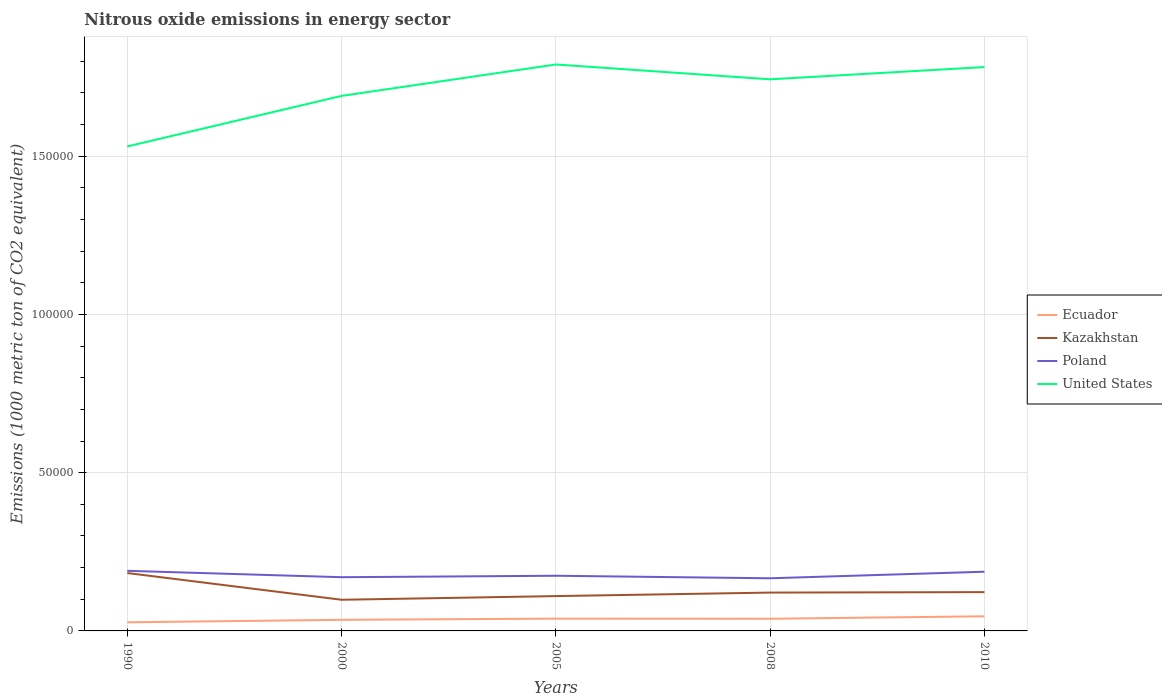Does the line corresponding to Kazakhstan intersect with the line corresponding to Ecuador?
Ensure brevity in your answer.  No. Is the number of lines equal to the number of legend labels?
Provide a succinct answer. Yes. Across all years, what is the maximum amount of nitrous oxide emitted in Kazakhstan?
Ensure brevity in your answer.  9844.3. In which year was the amount of nitrous oxide emitted in Poland maximum?
Your answer should be very brief. 2008. What is the total amount of nitrous oxide emitted in Kazakhstan in the graph?
Your answer should be compact. 7287.5. What is the difference between the highest and the second highest amount of nitrous oxide emitted in Kazakhstan?
Your answer should be compact. 8448.2. Is the amount of nitrous oxide emitted in Kazakhstan strictly greater than the amount of nitrous oxide emitted in United States over the years?
Provide a short and direct response. Yes. How many lines are there?
Offer a very short reply. 4. Are the values on the major ticks of Y-axis written in scientific E-notation?
Make the answer very short. No. Where does the legend appear in the graph?
Provide a short and direct response. Center right. How are the legend labels stacked?
Provide a succinct answer. Vertical. What is the title of the graph?
Make the answer very short. Nitrous oxide emissions in energy sector. What is the label or title of the X-axis?
Give a very brief answer. Years. What is the label or title of the Y-axis?
Make the answer very short. Emissions (1000 metric ton of CO2 equivalent). What is the Emissions (1000 metric ton of CO2 equivalent) in Ecuador in 1990?
Provide a short and direct response. 2718.5. What is the Emissions (1000 metric ton of CO2 equivalent) in Kazakhstan in 1990?
Give a very brief answer. 1.83e+04. What is the Emissions (1000 metric ton of CO2 equivalent) of Poland in 1990?
Your answer should be very brief. 1.90e+04. What is the Emissions (1000 metric ton of CO2 equivalent) in United States in 1990?
Your response must be concise. 1.53e+05. What is the Emissions (1000 metric ton of CO2 equivalent) of Ecuador in 2000?
Make the answer very short. 3508.3. What is the Emissions (1000 metric ton of CO2 equivalent) in Kazakhstan in 2000?
Your answer should be compact. 9844.3. What is the Emissions (1000 metric ton of CO2 equivalent) of Poland in 2000?
Make the answer very short. 1.70e+04. What is the Emissions (1000 metric ton of CO2 equivalent) of United States in 2000?
Your answer should be very brief. 1.69e+05. What is the Emissions (1000 metric ton of CO2 equivalent) in Ecuador in 2005?
Offer a terse response. 3878.5. What is the Emissions (1000 metric ton of CO2 equivalent) of Kazakhstan in 2005?
Your answer should be compact. 1.10e+04. What is the Emissions (1000 metric ton of CO2 equivalent) in Poland in 2005?
Your response must be concise. 1.74e+04. What is the Emissions (1000 metric ton of CO2 equivalent) of United States in 2005?
Your answer should be very brief. 1.79e+05. What is the Emissions (1000 metric ton of CO2 equivalent) of Ecuador in 2008?
Provide a succinct answer. 3846. What is the Emissions (1000 metric ton of CO2 equivalent) of Kazakhstan in 2008?
Your answer should be compact. 1.21e+04. What is the Emissions (1000 metric ton of CO2 equivalent) of Poland in 2008?
Provide a short and direct response. 1.66e+04. What is the Emissions (1000 metric ton of CO2 equivalent) of United States in 2008?
Provide a short and direct response. 1.74e+05. What is the Emissions (1000 metric ton of CO2 equivalent) of Ecuador in 2010?
Your answer should be very brief. 4620.6. What is the Emissions (1000 metric ton of CO2 equivalent) of Kazakhstan in 2010?
Provide a short and direct response. 1.23e+04. What is the Emissions (1000 metric ton of CO2 equivalent) in Poland in 2010?
Offer a terse response. 1.87e+04. What is the Emissions (1000 metric ton of CO2 equivalent) of United States in 2010?
Your answer should be very brief. 1.78e+05. Across all years, what is the maximum Emissions (1000 metric ton of CO2 equivalent) in Ecuador?
Give a very brief answer. 4620.6. Across all years, what is the maximum Emissions (1000 metric ton of CO2 equivalent) in Kazakhstan?
Your response must be concise. 1.83e+04. Across all years, what is the maximum Emissions (1000 metric ton of CO2 equivalent) in Poland?
Ensure brevity in your answer.  1.90e+04. Across all years, what is the maximum Emissions (1000 metric ton of CO2 equivalent) in United States?
Your answer should be compact. 1.79e+05. Across all years, what is the minimum Emissions (1000 metric ton of CO2 equivalent) in Ecuador?
Offer a terse response. 2718.5. Across all years, what is the minimum Emissions (1000 metric ton of CO2 equivalent) in Kazakhstan?
Keep it short and to the point. 9844.3. Across all years, what is the minimum Emissions (1000 metric ton of CO2 equivalent) of Poland?
Your answer should be compact. 1.66e+04. Across all years, what is the minimum Emissions (1000 metric ton of CO2 equivalent) of United States?
Your answer should be compact. 1.53e+05. What is the total Emissions (1000 metric ton of CO2 equivalent) in Ecuador in the graph?
Provide a succinct answer. 1.86e+04. What is the total Emissions (1000 metric ton of CO2 equivalent) in Kazakhstan in the graph?
Make the answer very short. 6.35e+04. What is the total Emissions (1000 metric ton of CO2 equivalent) of Poland in the graph?
Your answer should be compact. 8.87e+04. What is the total Emissions (1000 metric ton of CO2 equivalent) in United States in the graph?
Keep it short and to the point. 8.54e+05. What is the difference between the Emissions (1000 metric ton of CO2 equivalent) in Ecuador in 1990 and that in 2000?
Give a very brief answer. -789.8. What is the difference between the Emissions (1000 metric ton of CO2 equivalent) of Kazakhstan in 1990 and that in 2000?
Provide a short and direct response. 8448.2. What is the difference between the Emissions (1000 metric ton of CO2 equivalent) of Poland in 1990 and that in 2000?
Offer a very short reply. 2018.2. What is the difference between the Emissions (1000 metric ton of CO2 equivalent) in United States in 1990 and that in 2000?
Offer a very short reply. -1.60e+04. What is the difference between the Emissions (1000 metric ton of CO2 equivalent) in Ecuador in 1990 and that in 2005?
Provide a succinct answer. -1160. What is the difference between the Emissions (1000 metric ton of CO2 equivalent) in Kazakhstan in 1990 and that in 2005?
Your answer should be compact. 7287.5. What is the difference between the Emissions (1000 metric ton of CO2 equivalent) of Poland in 1990 and that in 2005?
Provide a succinct answer. 1561.1. What is the difference between the Emissions (1000 metric ton of CO2 equivalent) of United States in 1990 and that in 2005?
Give a very brief answer. -2.59e+04. What is the difference between the Emissions (1000 metric ton of CO2 equivalent) of Ecuador in 1990 and that in 2008?
Offer a terse response. -1127.5. What is the difference between the Emissions (1000 metric ton of CO2 equivalent) in Kazakhstan in 1990 and that in 2008?
Your answer should be compact. 6177.4. What is the difference between the Emissions (1000 metric ton of CO2 equivalent) in Poland in 1990 and that in 2008?
Ensure brevity in your answer.  2360.6. What is the difference between the Emissions (1000 metric ton of CO2 equivalent) of United States in 1990 and that in 2008?
Offer a very short reply. -2.12e+04. What is the difference between the Emissions (1000 metric ton of CO2 equivalent) in Ecuador in 1990 and that in 2010?
Make the answer very short. -1902.1. What is the difference between the Emissions (1000 metric ton of CO2 equivalent) in Kazakhstan in 1990 and that in 2010?
Your answer should be very brief. 6035.5. What is the difference between the Emissions (1000 metric ton of CO2 equivalent) in Poland in 1990 and that in 2010?
Offer a very short reply. 287.1. What is the difference between the Emissions (1000 metric ton of CO2 equivalent) of United States in 1990 and that in 2010?
Make the answer very short. -2.51e+04. What is the difference between the Emissions (1000 metric ton of CO2 equivalent) in Ecuador in 2000 and that in 2005?
Provide a short and direct response. -370.2. What is the difference between the Emissions (1000 metric ton of CO2 equivalent) in Kazakhstan in 2000 and that in 2005?
Keep it short and to the point. -1160.7. What is the difference between the Emissions (1000 metric ton of CO2 equivalent) of Poland in 2000 and that in 2005?
Your answer should be very brief. -457.1. What is the difference between the Emissions (1000 metric ton of CO2 equivalent) in United States in 2000 and that in 2005?
Make the answer very short. -9931.2. What is the difference between the Emissions (1000 metric ton of CO2 equivalent) of Ecuador in 2000 and that in 2008?
Keep it short and to the point. -337.7. What is the difference between the Emissions (1000 metric ton of CO2 equivalent) of Kazakhstan in 2000 and that in 2008?
Keep it short and to the point. -2270.8. What is the difference between the Emissions (1000 metric ton of CO2 equivalent) in Poland in 2000 and that in 2008?
Your answer should be compact. 342.4. What is the difference between the Emissions (1000 metric ton of CO2 equivalent) in United States in 2000 and that in 2008?
Your response must be concise. -5242.4. What is the difference between the Emissions (1000 metric ton of CO2 equivalent) of Ecuador in 2000 and that in 2010?
Offer a terse response. -1112.3. What is the difference between the Emissions (1000 metric ton of CO2 equivalent) in Kazakhstan in 2000 and that in 2010?
Offer a terse response. -2412.7. What is the difference between the Emissions (1000 metric ton of CO2 equivalent) in Poland in 2000 and that in 2010?
Give a very brief answer. -1731.1. What is the difference between the Emissions (1000 metric ton of CO2 equivalent) in United States in 2000 and that in 2010?
Provide a succinct answer. -9113.5. What is the difference between the Emissions (1000 metric ton of CO2 equivalent) in Ecuador in 2005 and that in 2008?
Provide a succinct answer. 32.5. What is the difference between the Emissions (1000 metric ton of CO2 equivalent) in Kazakhstan in 2005 and that in 2008?
Give a very brief answer. -1110.1. What is the difference between the Emissions (1000 metric ton of CO2 equivalent) of Poland in 2005 and that in 2008?
Your answer should be very brief. 799.5. What is the difference between the Emissions (1000 metric ton of CO2 equivalent) of United States in 2005 and that in 2008?
Give a very brief answer. 4688.8. What is the difference between the Emissions (1000 metric ton of CO2 equivalent) of Ecuador in 2005 and that in 2010?
Your answer should be very brief. -742.1. What is the difference between the Emissions (1000 metric ton of CO2 equivalent) of Kazakhstan in 2005 and that in 2010?
Your answer should be compact. -1252. What is the difference between the Emissions (1000 metric ton of CO2 equivalent) in Poland in 2005 and that in 2010?
Keep it short and to the point. -1274. What is the difference between the Emissions (1000 metric ton of CO2 equivalent) of United States in 2005 and that in 2010?
Your answer should be very brief. 817.7. What is the difference between the Emissions (1000 metric ton of CO2 equivalent) of Ecuador in 2008 and that in 2010?
Offer a terse response. -774.6. What is the difference between the Emissions (1000 metric ton of CO2 equivalent) of Kazakhstan in 2008 and that in 2010?
Offer a very short reply. -141.9. What is the difference between the Emissions (1000 metric ton of CO2 equivalent) of Poland in 2008 and that in 2010?
Your response must be concise. -2073.5. What is the difference between the Emissions (1000 metric ton of CO2 equivalent) of United States in 2008 and that in 2010?
Your answer should be compact. -3871.1. What is the difference between the Emissions (1000 metric ton of CO2 equivalent) of Ecuador in 1990 and the Emissions (1000 metric ton of CO2 equivalent) of Kazakhstan in 2000?
Provide a succinct answer. -7125.8. What is the difference between the Emissions (1000 metric ton of CO2 equivalent) in Ecuador in 1990 and the Emissions (1000 metric ton of CO2 equivalent) in Poland in 2000?
Your answer should be very brief. -1.43e+04. What is the difference between the Emissions (1000 metric ton of CO2 equivalent) of Ecuador in 1990 and the Emissions (1000 metric ton of CO2 equivalent) of United States in 2000?
Ensure brevity in your answer.  -1.66e+05. What is the difference between the Emissions (1000 metric ton of CO2 equivalent) of Kazakhstan in 1990 and the Emissions (1000 metric ton of CO2 equivalent) of Poland in 2000?
Your answer should be compact. 1320. What is the difference between the Emissions (1000 metric ton of CO2 equivalent) in Kazakhstan in 1990 and the Emissions (1000 metric ton of CO2 equivalent) in United States in 2000?
Provide a short and direct response. -1.51e+05. What is the difference between the Emissions (1000 metric ton of CO2 equivalent) of Poland in 1990 and the Emissions (1000 metric ton of CO2 equivalent) of United States in 2000?
Offer a very short reply. -1.50e+05. What is the difference between the Emissions (1000 metric ton of CO2 equivalent) of Ecuador in 1990 and the Emissions (1000 metric ton of CO2 equivalent) of Kazakhstan in 2005?
Keep it short and to the point. -8286.5. What is the difference between the Emissions (1000 metric ton of CO2 equivalent) in Ecuador in 1990 and the Emissions (1000 metric ton of CO2 equivalent) in Poland in 2005?
Your answer should be very brief. -1.47e+04. What is the difference between the Emissions (1000 metric ton of CO2 equivalent) in Ecuador in 1990 and the Emissions (1000 metric ton of CO2 equivalent) in United States in 2005?
Offer a terse response. -1.76e+05. What is the difference between the Emissions (1000 metric ton of CO2 equivalent) in Kazakhstan in 1990 and the Emissions (1000 metric ton of CO2 equivalent) in Poland in 2005?
Keep it short and to the point. 862.9. What is the difference between the Emissions (1000 metric ton of CO2 equivalent) in Kazakhstan in 1990 and the Emissions (1000 metric ton of CO2 equivalent) in United States in 2005?
Offer a terse response. -1.61e+05. What is the difference between the Emissions (1000 metric ton of CO2 equivalent) in Poland in 1990 and the Emissions (1000 metric ton of CO2 equivalent) in United States in 2005?
Your answer should be very brief. -1.60e+05. What is the difference between the Emissions (1000 metric ton of CO2 equivalent) in Ecuador in 1990 and the Emissions (1000 metric ton of CO2 equivalent) in Kazakhstan in 2008?
Your answer should be very brief. -9396.6. What is the difference between the Emissions (1000 metric ton of CO2 equivalent) of Ecuador in 1990 and the Emissions (1000 metric ton of CO2 equivalent) of Poland in 2008?
Give a very brief answer. -1.39e+04. What is the difference between the Emissions (1000 metric ton of CO2 equivalent) of Ecuador in 1990 and the Emissions (1000 metric ton of CO2 equivalent) of United States in 2008?
Keep it short and to the point. -1.72e+05. What is the difference between the Emissions (1000 metric ton of CO2 equivalent) of Kazakhstan in 1990 and the Emissions (1000 metric ton of CO2 equivalent) of Poland in 2008?
Make the answer very short. 1662.4. What is the difference between the Emissions (1000 metric ton of CO2 equivalent) of Kazakhstan in 1990 and the Emissions (1000 metric ton of CO2 equivalent) of United States in 2008?
Make the answer very short. -1.56e+05. What is the difference between the Emissions (1000 metric ton of CO2 equivalent) of Poland in 1990 and the Emissions (1000 metric ton of CO2 equivalent) of United States in 2008?
Your answer should be compact. -1.55e+05. What is the difference between the Emissions (1000 metric ton of CO2 equivalent) of Ecuador in 1990 and the Emissions (1000 metric ton of CO2 equivalent) of Kazakhstan in 2010?
Provide a succinct answer. -9538.5. What is the difference between the Emissions (1000 metric ton of CO2 equivalent) in Ecuador in 1990 and the Emissions (1000 metric ton of CO2 equivalent) in Poland in 2010?
Ensure brevity in your answer.  -1.60e+04. What is the difference between the Emissions (1000 metric ton of CO2 equivalent) in Ecuador in 1990 and the Emissions (1000 metric ton of CO2 equivalent) in United States in 2010?
Provide a succinct answer. -1.75e+05. What is the difference between the Emissions (1000 metric ton of CO2 equivalent) in Kazakhstan in 1990 and the Emissions (1000 metric ton of CO2 equivalent) in Poland in 2010?
Your answer should be very brief. -411.1. What is the difference between the Emissions (1000 metric ton of CO2 equivalent) in Kazakhstan in 1990 and the Emissions (1000 metric ton of CO2 equivalent) in United States in 2010?
Your response must be concise. -1.60e+05. What is the difference between the Emissions (1000 metric ton of CO2 equivalent) of Poland in 1990 and the Emissions (1000 metric ton of CO2 equivalent) of United States in 2010?
Your response must be concise. -1.59e+05. What is the difference between the Emissions (1000 metric ton of CO2 equivalent) of Ecuador in 2000 and the Emissions (1000 metric ton of CO2 equivalent) of Kazakhstan in 2005?
Your response must be concise. -7496.7. What is the difference between the Emissions (1000 metric ton of CO2 equivalent) of Ecuador in 2000 and the Emissions (1000 metric ton of CO2 equivalent) of Poland in 2005?
Give a very brief answer. -1.39e+04. What is the difference between the Emissions (1000 metric ton of CO2 equivalent) in Ecuador in 2000 and the Emissions (1000 metric ton of CO2 equivalent) in United States in 2005?
Offer a terse response. -1.75e+05. What is the difference between the Emissions (1000 metric ton of CO2 equivalent) of Kazakhstan in 2000 and the Emissions (1000 metric ton of CO2 equivalent) of Poland in 2005?
Provide a short and direct response. -7585.3. What is the difference between the Emissions (1000 metric ton of CO2 equivalent) of Kazakhstan in 2000 and the Emissions (1000 metric ton of CO2 equivalent) of United States in 2005?
Ensure brevity in your answer.  -1.69e+05. What is the difference between the Emissions (1000 metric ton of CO2 equivalent) of Poland in 2000 and the Emissions (1000 metric ton of CO2 equivalent) of United States in 2005?
Your response must be concise. -1.62e+05. What is the difference between the Emissions (1000 metric ton of CO2 equivalent) of Ecuador in 2000 and the Emissions (1000 metric ton of CO2 equivalent) of Kazakhstan in 2008?
Keep it short and to the point. -8606.8. What is the difference between the Emissions (1000 metric ton of CO2 equivalent) of Ecuador in 2000 and the Emissions (1000 metric ton of CO2 equivalent) of Poland in 2008?
Make the answer very short. -1.31e+04. What is the difference between the Emissions (1000 metric ton of CO2 equivalent) in Ecuador in 2000 and the Emissions (1000 metric ton of CO2 equivalent) in United States in 2008?
Provide a short and direct response. -1.71e+05. What is the difference between the Emissions (1000 metric ton of CO2 equivalent) of Kazakhstan in 2000 and the Emissions (1000 metric ton of CO2 equivalent) of Poland in 2008?
Offer a terse response. -6785.8. What is the difference between the Emissions (1000 metric ton of CO2 equivalent) of Kazakhstan in 2000 and the Emissions (1000 metric ton of CO2 equivalent) of United States in 2008?
Ensure brevity in your answer.  -1.64e+05. What is the difference between the Emissions (1000 metric ton of CO2 equivalent) in Poland in 2000 and the Emissions (1000 metric ton of CO2 equivalent) in United States in 2008?
Keep it short and to the point. -1.57e+05. What is the difference between the Emissions (1000 metric ton of CO2 equivalent) in Ecuador in 2000 and the Emissions (1000 metric ton of CO2 equivalent) in Kazakhstan in 2010?
Your answer should be compact. -8748.7. What is the difference between the Emissions (1000 metric ton of CO2 equivalent) in Ecuador in 2000 and the Emissions (1000 metric ton of CO2 equivalent) in Poland in 2010?
Give a very brief answer. -1.52e+04. What is the difference between the Emissions (1000 metric ton of CO2 equivalent) of Ecuador in 2000 and the Emissions (1000 metric ton of CO2 equivalent) of United States in 2010?
Give a very brief answer. -1.75e+05. What is the difference between the Emissions (1000 metric ton of CO2 equivalent) of Kazakhstan in 2000 and the Emissions (1000 metric ton of CO2 equivalent) of Poland in 2010?
Ensure brevity in your answer.  -8859.3. What is the difference between the Emissions (1000 metric ton of CO2 equivalent) in Kazakhstan in 2000 and the Emissions (1000 metric ton of CO2 equivalent) in United States in 2010?
Provide a short and direct response. -1.68e+05. What is the difference between the Emissions (1000 metric ton of CO2 equivalent) of Poland in 2000 and the Emissions (1000 metric ton of CO2 equivalent) of United States in 2010?
Offer a very short reply. -1.61e+05. What is the difference between the Emissions (1000 metric ton of CO2 equivalent) of Ecuador in 2005 and the Emissions (1000 metric ton of CO2 equivalent) of Kazakhstan in 2008?
Your answer should be very brief. -8236.6. What is the difference between the Emissions (1000 metric ton of CO2 equivalent) in Ecuador in 2005 and the Emissions (1000 metric ton of CO2 equivalent) in Poland in 2008?
Offer a very short reply. -1.28e+04. What is the difference between the Emissions (1000 metric ton of CO2 equivalent) of Ecuador in 2005 and the Emissions (1000 metric ton of CO2 equivalent) of United States in 2008?
Your response must be concise. -1.70e+05. What is the difference between the Emissions (1000 metric ton of CO2 equivalent) of Kazakhstan in 2005 and the Emissions (1000 metric ton of CO2 equivalent) of Poland in 2008?
Provide a short and direct response. -5625.1. What is the difference between the Emissions (1000 metric ton of CO2 equivalent) of Kazakhstan in 2005 and the Emissions (1000 metric ton of CO2 equivalent) of United States in 2008?
Give a very brief answer. -1.63e+05. What is the difference between the Emissions (1000 metric ton of CO2 equivalent) in Poland in 2005 and the Emissions (1000 metric ton of CO2 equivalent) in United States in 2008?
Give a very brief answer. -1.57e+05. What is the difference between the Emissions (1000 metric ton of CO2 equivalent) in Ecuador in 2005 and the Emissions (1000 metric ton of CO2 equivalent) in Kazakhstan in 2010?
Your answer should be very brief. -8378.5. What is the difference between the Emissions (1000 metric ton of CO2 equivalent) in Ecuador in 2005 and the Emissions (1000 metric ton of CO2 equivalent) in Poland in 2010?
Make the answer very short. -1.48e+04. What is the difference between the Emissions (1000 metric ton of CO2 equivalent) in Ecuador in 2005 and the Emissions (1000 metric ton of CO2 equivalent) in United States in 2010?
Offer a very short reply. -1.74e+05. What is the difference between the Emissions (1000 metric ton of CO2 equivalent) of Kazakhstan in 2005 and the Emissions (1000 metric ton of CO2 equivalent) of Poland in 2010?
Provide a succinct answer. -7698.6. What is the difference between the Emissions (1000 metric ton of CO2 equivalent) in Kazakhstan in 2005 and the Emissions (1000 metric ton of CO2 equivalent) in United States in 2010?
Provide a succinct answer. -1.67e+05. What is the difference between the Emissions (1000 metric ton of CO2 equivalent) of Poland in 2005 and the Emissions (1000 metric ton of CO2 equivalent) of United States in 2010?
Your answer should be compact. -1.61e+05. What is the difference between the Emissions (1000 metric ton of CO2 equivalent) of Ecuador in 2008 and the Emissions (1000 metric ton of CO2 equivalent) of Kazakhstan in 2010?
Your answer should be very brief. -8411. What is the difference between the Emissions (1000 metric ton of CO2 equivalent) in Ecuador in 2008 and the Emissions (1000 metric ton of CO2 equivalent) in Poland in 2010?
Ensure brevity in your answer.  -1.49e+04. What is the difference between the Emissions (1000 metric ton of CO2 equivalent) in Ecuador in 2008 and the Emissions (1000 metric ton of CO2 equivalent) in United States in 2010?
Keep it short and to the point. -1.74e+05. What is the difference between the Emissions (1000 metric ton of CO2 equivalent) of Kazakhstan in 2008 and the Emissions (1000 metric ton of CO2 equivalent) of Poland in 2010?
Keep it short and to the point. -6588.5. What is the difference between the Emissions (1000 metric ton of CO2 equivalent) in Kazakhstan in 2008 and the Emissions (1000 metric ton of CO2 equivalent) in United States in 2010?
Ensure brevity in your answer.  -1.66e+05. What is the difference between the Emissions (1000 metric ton of CO2 equivalent) in Poland in 2008 and the Emissions (1000 metric ton of CO2 equivalent) in United States in 2010?
Keep it short and to the point. -1.62e+05. What is the average Emissions (1000 metric ton of CO2 equivalent) of Ecuador per year?
Your answer should be very brief. 3714.38. What is the average Emissions (1000 metric ton of CO2 equivalent) of Kazakhstan per year?
Give a very brief answer. 1.27e+04. What is the average Emissions (1000 metric ton of CO2 equivalent) of Poland per year?
Make the answer very short. 1.77e+04. What is the average Emissions (1000 metric ton of CO2 equivalent) of United States per year?
Your response must be concise. 1.71e+05. In the year 1990, what is the difference between the Emissions (1000 metric ton of CO2 equivalent) of Ecuador and Emissions (1000 metric ton of CO2 equivalent) of Kazakhstan?
Ensure brevity in your answer.  -1.56e+04. In the year 1990, what is the difference between the Emissions (1000 metric ton of CO2 equivalent) in Ecuador and Emissions (1000 metric ton of CO2 equivalent) in Poland?
Your answer should be very brief. -1.63e+04. In the year 1990, what is the difference between the Emissions (1000 metric ton of CO2 equivalent) in Ecuador and Emissions (1000 metric ton of CO2 equivalent) in United States?
Offer a terse response. -1.50e+05. In the year 1990, what is the difference between the Emissions (1000 metric ton of CO2 equivalent) in Kazakhstan and Emissions (1000 metric ton of CO2 equivalent) in Poland?
Give a very brief answer. -698.2. In the year 1990, what is the difference between the Emissions (1000 metric ton of CO2 equivalent) in Kazakhstan and Emissions (1000 metric ton of CO2 equivalent) in United States?
Make the answer very short. -1.35e+05. In the year 1990, what is the difference between the Emissions (1000 metric ton of CO2 equivalent) of Poland and Emissions (1000 metric ton of CO2 equivalent) of United States?
Keep it short and to the point. -1.34e+05. In the year 2000, what is the difference between the Emissions (1000 metric ton of CO2 equivalent) of Ecuador and Emissions (1000 metric ton of CO2 equivalent) of Kazakhstan?
Keep it short and to the point. -6336. In the year 2000, what is the difference between the Emissions (1000 metric ton of CO2 equivalent) in Ecuador and Emissions (1000 metric ton of CO2 equivalent) in Poland?
Give a very brief answer. -1.35e+04. In the year 2000, what is the difference between the Emissions (1000 metric ton of CO2 equivalent) of Ecuador and Emissions (1000 metric ton of CO2 equivalent) of United States?
Keep it short and to the point. -1.66e+05. In the year 2000, what is the difference between the Emissions (1000 metric ton of CO2 equivalent) of Kazakhstan and Emissions (1000 metric ton of CO2 equivalent) of Poland?
Offer a terse response. -7128.2. In the year 2000, what is the difference between the Emissions (1000 metric ton of CO2 equivalent) of Kazakhstan and Emissions (1000 metric ton of CO2 equivalent) of United States?
Ensure brevity in your answer.  -1.59e+05. In the year 2000, what is the difference between the Emissions (1000 metric ton of CO2 equivalent) of Poland and Emissions (1000 metric ton of CO2 equivalent) of United States?
Provide a short and direct response. -1.52e+05. In the year 2005, what is the difference between the Emissions (1000 metric ton of CO2 equivalent) of Ecuador and Emissions (1000 metric ton of CO2 equivalent) of Kazakhstan?
Keep it short and to the point. -7126.5. In the year 2005, what is the difference between the Emissions (1000 metric ton of CO2 equivalent) in Ecuador and Emissions (1000 metric ton of CO2 equivalent) in Poland?
Provide a short and direct response. -1.36e+04. In the year 2005, what is the difference between the Emissions (1000 metric ton of CO2 equivalent) of Ecuador and Emissions (1000 metric ton of CO2 equivalent) of United States?
Your response must be concise. -1.75e+05. In the year 2005, what is the difference between the Emissions (1000 metric ton of CO2 equivalent) of Kazakhstan and Emissions (1000 metric ton of CO2 equivalent) of Poland?
Your response must be concise. -6424.6. In the year 2005, what is the difference between the Emissions (1000 metric ton of CO2 equivalent) of Kazakhstan and Emissions (1000 metric ton of CO2 equivalent) of United States?
Keep it short and to the point. -1.68e+05. In the year 2005, what is the difference between the Emissions (1000 metric ton of CO2 equivalent) of Poland and Emissions (1000 metric ton of CO2 equivalent) of United States?
Provide a succinct answer. -1.62e+05. In the year 2008, what is the difference between the Emissions (1000 metric ton of CO2 equivalent) in Ecuador and Emissions (1000 metric ton of CO2 equivalent) in Kazakhstan?
Provide a short and direct response. -8269.1. In the year 2008, what is the difference between the Emissions (1000 metric ton of CO2 equivalent) of Ecuador and Emissions (1000 metric ton of CO2 equivalent) of Poland?
Provide a succinct answer. -1.28e+04. In the year 2008, what is the difference between the Emissions (1000 metric ton of CO2 equivalent) in Ecuador and Emissions (1000 metric ton of CO2 equivalent) in United States?
Keep it short and to the point. -1.70e+05. In the year 2008, what is the difference between the Emissions (1000 metric ton of CO2 equivalent) of Kazakhstan and Emissions (1000 metric ton of CO2 equivalent) of Poland?
Give a very brief answer. -4515. In the year 2008, what is the difference between the Emissions (1000 metric ton of CO2 equivalent) of Kazakhstan and Emissions (1000 metric ton of CO2 equivalent) of United States?
Ensure brevity in your answer.  -1.62e+05. In the year 2008, what is the difference between the Emissions (1000 metric ton of CO2 equivalent) in Poland and Emissions (1000 metric ton of CO2 equivalent) in United States?
Make the answer very short. -1.58e+05. In the year 2010, what is the difference between the Emissions (1000 metric ton of CO2 equivalent) in Ecuador and Emissions (1000 metric ton of CO2 equivalent) in Kazakhstan?
Your answer should be very brief. -7636.4. In the year 2010, what is the difference between the Emissions (1000 metric ton of CO2 equivalent) of Ecuador and Emissions (1000 metric ton of CO2 equivalent) of Poland?
Keep it short and to the point. -1.41e+04. In the year 2010, what is the difference between the Emissions (1000 metric ton of CO2 equivalent) in Ecuador and Emissions (1000 metric ton of CO2 equivalent) in United States?
Give a very brief answer. -1.74e+05. In the year 2010, what is the difference between the Emissions (1000 metric ton of CO2 equivalent) of Kazakhstan and Emissions (1000 metric ton of CO2 equivalent) of Poland?
Your answer should be compact. -6446.6. In the year 2010, what is the difference between the Emissions (1000 metric ton of CO2 equivalent) of Kazakhstan and Emissions (1000 metric ton of CO2 equivalent) of United States?
Offer a very short reply. -1.66e+05. In the year 2010, what is the difference between the Emissions (1000 metric ton of CO2 equivalent) in Poland and Emissions (1000 metric ton of CO2 equivalent) in United States?
Make the answer very short. -1.59e+05. What is the ratio of the Emissions (1000 metric ton of CO2 equivalent) of Ecuador in 1990 to that in 2000?
Ensure brevity in your answer.  0.77. What is the ratio of the Emissions (1000 metric ton of CO2 equivalent) of Kazakhstan in 1990 to that in 2000?
Ensure brevity in your answer.  1.86. What is the ratio of the Emissions (1000 metric ton of CO2 equivalent) of Poland in 1990 to that in 2000?
Your answer should be compact. 1.12. What is the ratio of the Emissions (1000 metric ton of CO2 equivalent) in United States in 1990 to that in 2000?
Your response must be concise. 0.91. What is the ratio of the Emissions (1000 metric ton of CO2 equivalent) in Ecuador in 1990 to that in 2005?
Make the answer very short. 0.7. What is the ratio of the Emissions (1000 metric ton of CO2 equivalent) in Kazakhstan in 1990 to that in 2005?
Provide a succinct answer. 1.66. What is the ratio of the Emissions (1000 metric ton of CO2 equivalent) in Poland in 1990 to that in 2005?
Your response must be concise. 1.09. What is the ratio of the Emissions (1000 metric ton of CO2 equivalent) of United States in 1990 to that in 2005?
Make the answer very short. 0.86. What is the ratio of the Emissions (1000 metric ton of CO2 equivalent) of Ecuador in 1990 to that in 2008?
Give a very brief answer. 0.71. What is the ratio of the Emissions (1000 metric ton of CO2 equivalent) in Kazakhstan in 1990 to that in 2008?
Keep it short and to the point. 1.51. What is the ratio of the Emissions (1000 metric ton of CO2 equivalent) in Poland in 1990 to that in 2008?
Your answer should be compact. 1.14. What is the ratio of the Emissions (1000 metric ton of CO2 equivalent) of United States in 1990 to that in 2008?
Your answer should be compact. 0.88. What is the ratio of the Emissions (1000 metric ton of CO2 equivalent) of Ecuador in 1990 to that in 2010?
Make the answer very short. 0.59. What is the ratio of the Emissions (1000 metric ton of CO2 equivalent) in Kazakhstan in 1990 to that in 2010?
Your answer should be compact. 1.49. What is the ratio of the Emissions (1000 metric ton of CO2 equivalent) of Poland in 1990 to that in 2010?
Your answer should be very brief. 1.02. What is the ratio of the Emissions (1000 metric ton of CO2 equivalent) of United States in 1990 to that in 2010?
Keep it short and to the point. 0.86. What is the ratio of the Emissions (1000 metric ton of CO2 equivalent) of Ecuador in 2000 to that in 2005?
Provide a short and direct response. 0.9. What is the ratio of the Emissions (1000 metric ton of CO2 equivalent) in Kazakhstan in 2000 to that in 2005?
Provide a short and direct response. 0.89. What is the ratio of the Emissions (1000 metric ton of CO2 equivalent) in Poland in 2000 to that in 2005?
Offer a very short reply. 0.97. What is the ratio of the Emissions (1000 metric ton of CO2 equivalent) in United States in 2000 to that in 2005?
Offer a very short reply. 0.94. What is the ratio of the Emissions (1000 metric ton of CO2 equivalent) of Ecuador in 2000 to that in 2008?
Make the answer very short. 0.91. What is the ratio of the Emissions (1000 metric ton of CO2 equivalent) in Kazakhstan in 2000 to that in 2008?
Provide a short and direct response. 0.81. What is the ratio of the Emissions (1000 metric ton of CO2 equivalent) in Poland in 2000 to that in 2008?
Offer a terse response. 1.02. What is the ratio of the Emissions (1000 metric ton of CO2 equivalent) of United States in 2000 to that in 2008?
Offer a very short reply. 0.97. What is the ratio of the Emissions (1000 metric ton of CO2 equivalent) in Ecuador in 2000 to that in 2010?
Provide a short and direct response. 0.76. What is the ratio of the Emissions (1000 metric ton of CO2 equivalent) of Kazakhstan in 2000 to that in 2010?
Provide a succinct answer. 0.8. What is the ratio of the Emissions (1000 metric ton of CO2 equivalent) in Poland in 2000 to that in 2010?
Give a very brief answer. 0.91. What is the ratio of the Emissions (1000 metric ton of CO2 equivalent) in United States in 2000 to that in 2010?
Your response must be concise. 0.95. What is the ratio of the Emissions (1000 metric ton of CO2 equivalent) in Ecuador in 2005 to that in 2008?
Keep it short and to the point. 1.01. What is the ratio of the Emissions (1000 metric ton of CO2 equivalent) of Kazakhstan in 2005 to that in 2008?
Your answer should be compact. 0.91. What is the ratio of the Emissions (1000 metric ton of CO2 equivalent) in Poland in 2005 to that in 2008?
Your answer should be compact. 1.05. What is the ratio of the Emissions (1000 metric ton of CO2 equivalent) in United States in 2005 to that in 2008?
Your answer should be compact. 1.03. What is the ratio of the Emissions (1000 metric ton of CO2 equivalent) of Ecuador in 2005 to that in 2010?
Provide a succinct answer. 0.84. What is the ratio of the Emissions (1000 metric ton of CO2 equivalent) of Kazakhstan in 2005 to that in 2010?
Make the answer very short. 0.9. What is the ratio of the Emissions (1000 metric ton of CO2 equivalent) of Poland in 2005 to that in 2010?
Offer a very short reply. 0.93. What is the ratio of the Emissions (1000 metric ton of CO2 equivalent) of Ecuador in 2008 to that in 2010?
Provide a succinct answer. 0.83. What is the ratio of the Emissions (1000 metric ton of CO2 equivalent) of Kazakhstan in 2008 to that in 2010?
Give a very brief answer. 0.99. What is the ratio of the Emissions (1000 metric ton of CO2 equivalent) in Poland in 2008 to that in 2010?
Offer a very short reply. 0.89. What is the ratio of the Emissions (1000 metric ton of CO2 equivalent) in United States in 2008 to that in 2010?
Offer a very short reply. 0.98. What is the difference between the highest and the second highest Emissions (1000 metric ton of CO2 equivalent) in Ecuador?
Keep it short and to the point. 742.1. What is the difference between the highest and the second highest Emissions (1000 metric ton of CO2 equivalent) in Kazakhstan?
Your response must be concise. 6035.5. What is the difference between the highest and the second highest Emissions (1000 metric ton of CO2 equivalent) of Poland?
Offer a terse response. 287.1. What is the difference between the highest and the second highest Emissions (1000 metric ton of CO2 equivalent) in United States?
Ensure brevity in your answer.  817.7. What is the difference between the highest and the lowest Emissions (1000 metric ton of CO2 equivalent) of Ecuador?
Provide a succinct answer. 1902.1. What is the difference between the highest and the lowest Emissions (1000 metric ton of CO2 equivalent) in Kazakhstan?
Offer a very short reply. 8448.2. What is the difference between the highest and the lowest Emissions (1000 metric ton of CO2 equivalent) of Poland?
Your response must be concise. 2360.6. What is the difference between the highest and the lowest Emissions (1000 metric ton of CO2 equivalent) in United States?
Your answer should be compact. 2.59e+04. 